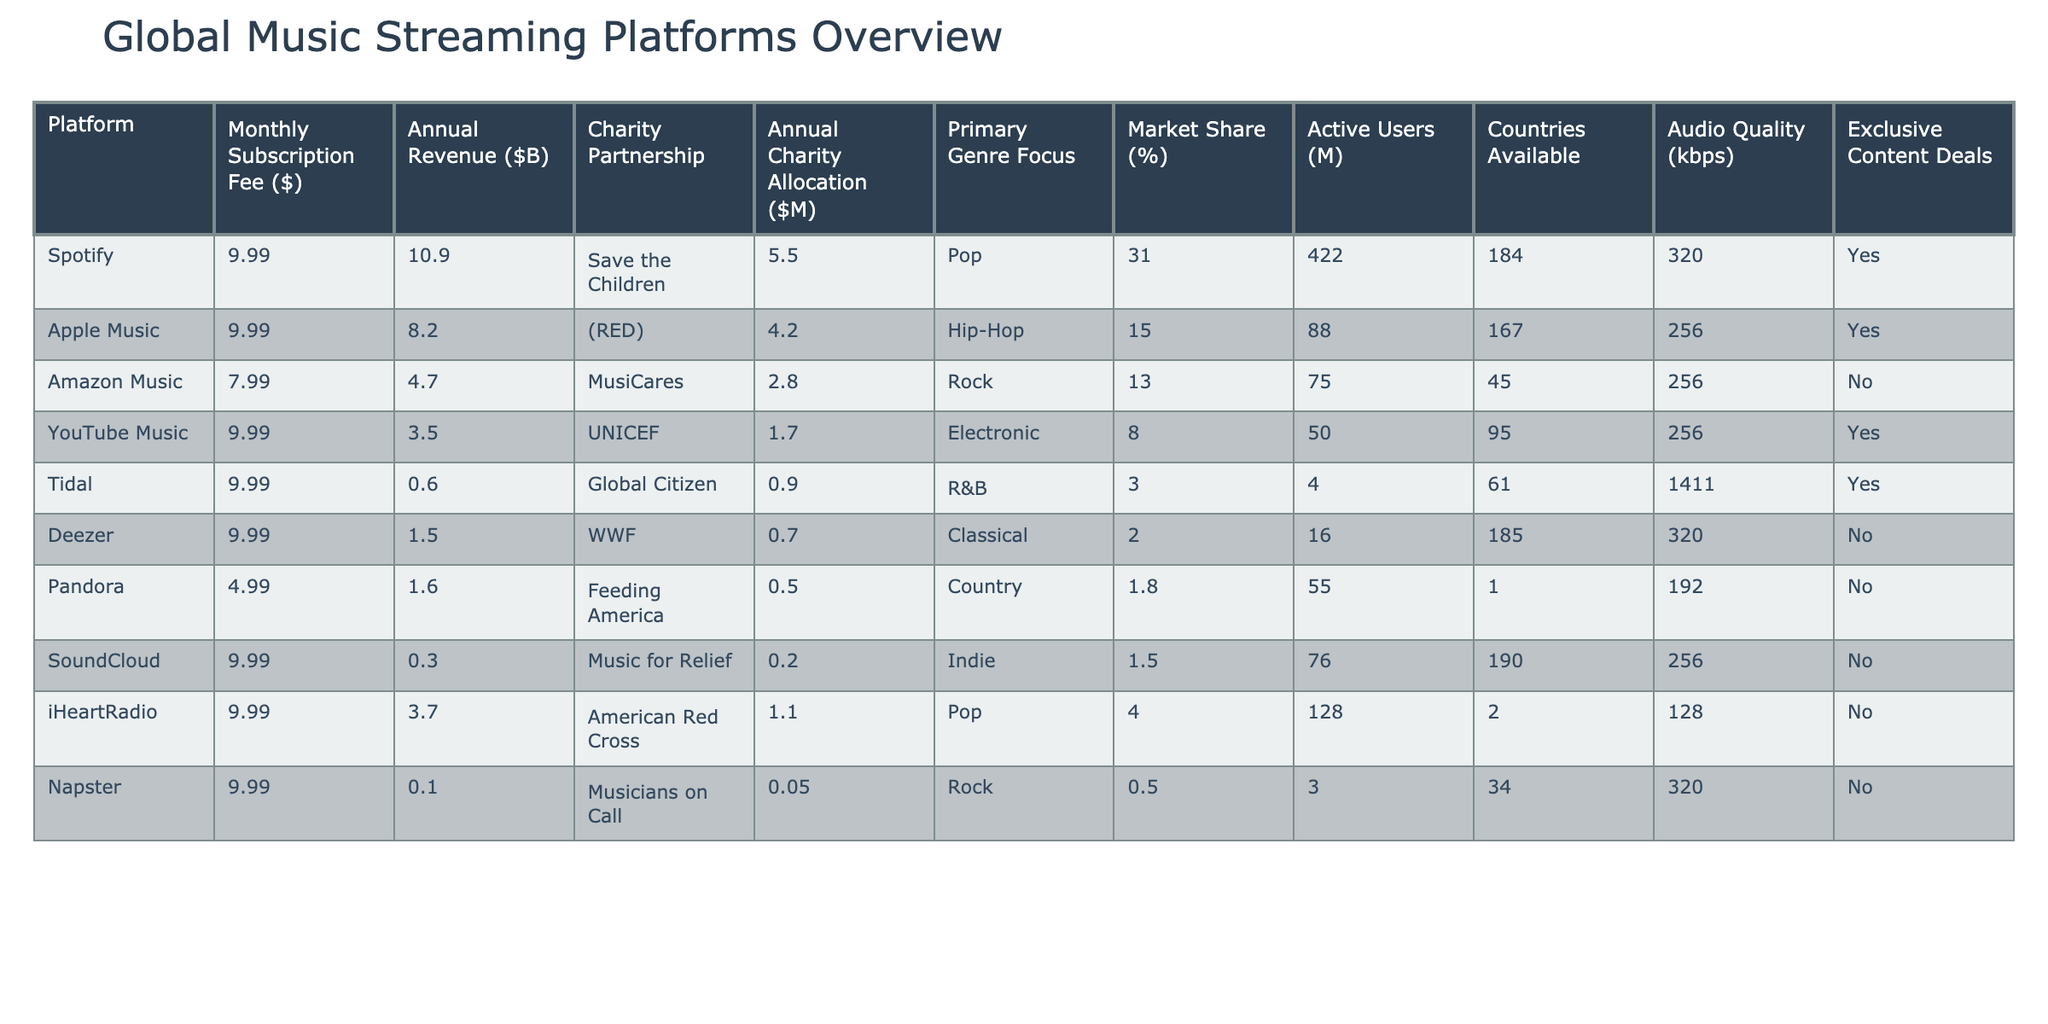What is the monthly subscription fee for Amazon Music? Amazon Music's entry in the table lists its monthly subscription fee directly, which is $7.99.
Answer: $7.99 Which platform has the largest annual charity allocation? By comparing the Annual Charity Allocation column, Save the Children receives the highest allocation at $5.5 million from Spotify.
Answer: $5.5 million What is the market share percentage of Apple Music? The table shows that Apple Music has a market share of 15%.
Answer: 15% How many platforms have annual charity allocations greater than $2 million? Reviewing the Annual Charity Allocation column, Spotify ($5.5M), Apple Music ($4.2M), and Amazon Music ($2.8M) exceed $2 million, totaling three platforms.
Answer: 3 Which genre does Tidal primarily focus on, and what is its annual revenue? Tidal focuses on R&B as its primary genre, and its annual revenue is $0.6 billion.
Answer: R&B, $0.6 billion Is there any platform that does not have exclusive content deals? Based on the Exclusive Content Deals column, both Amazon Music, Deezer, Pandora, SoundCloud, iHeartRadio, and Napster do not have exclusive deals.
Answer: Yes What is the average annual revenue of the platforms listed? Adding the annual revenues: 10.9 + 8.2 + 4.7 + 3.5 + 0.6 + 1.5 + 1.6 + 0.3 + 3.7 + 0.1 = 34.1 billion across 10 platforms gives an average of 34.1/10 = 3.41 billion.
Answer: $3.41 billion Which platform has the highest number of active users? The Active Users column reveals that Spotify has the highest number with 422 million users.
Answer: 422 million What is the total annual charity allocation for platforms focused on Pop music? The charity allocations for Pop music are from Spotify ($5.5M) and iHeartRadio ($1.1M), totaling $6.6 million.
Answer: $6.6 million How does the audio quality differ among the platforms? The Audio Quality column lists various kbps values. Tidal offers the highest at 1411 kbps, while Pandora has the lowest at 192 kbps.
Answer: Tidal: 1411 kbps, Pandora: 192 kbps What percentage of platforms provide charity partnerships focused on health-related initiatives? The platforms with health-related charity partnerships are Apple Music (with (RED)) and Amazon Music (with MusiCares), which amounts to 2 out of a total of 10 platforms, resulting in 20%.
Answer: 20% 